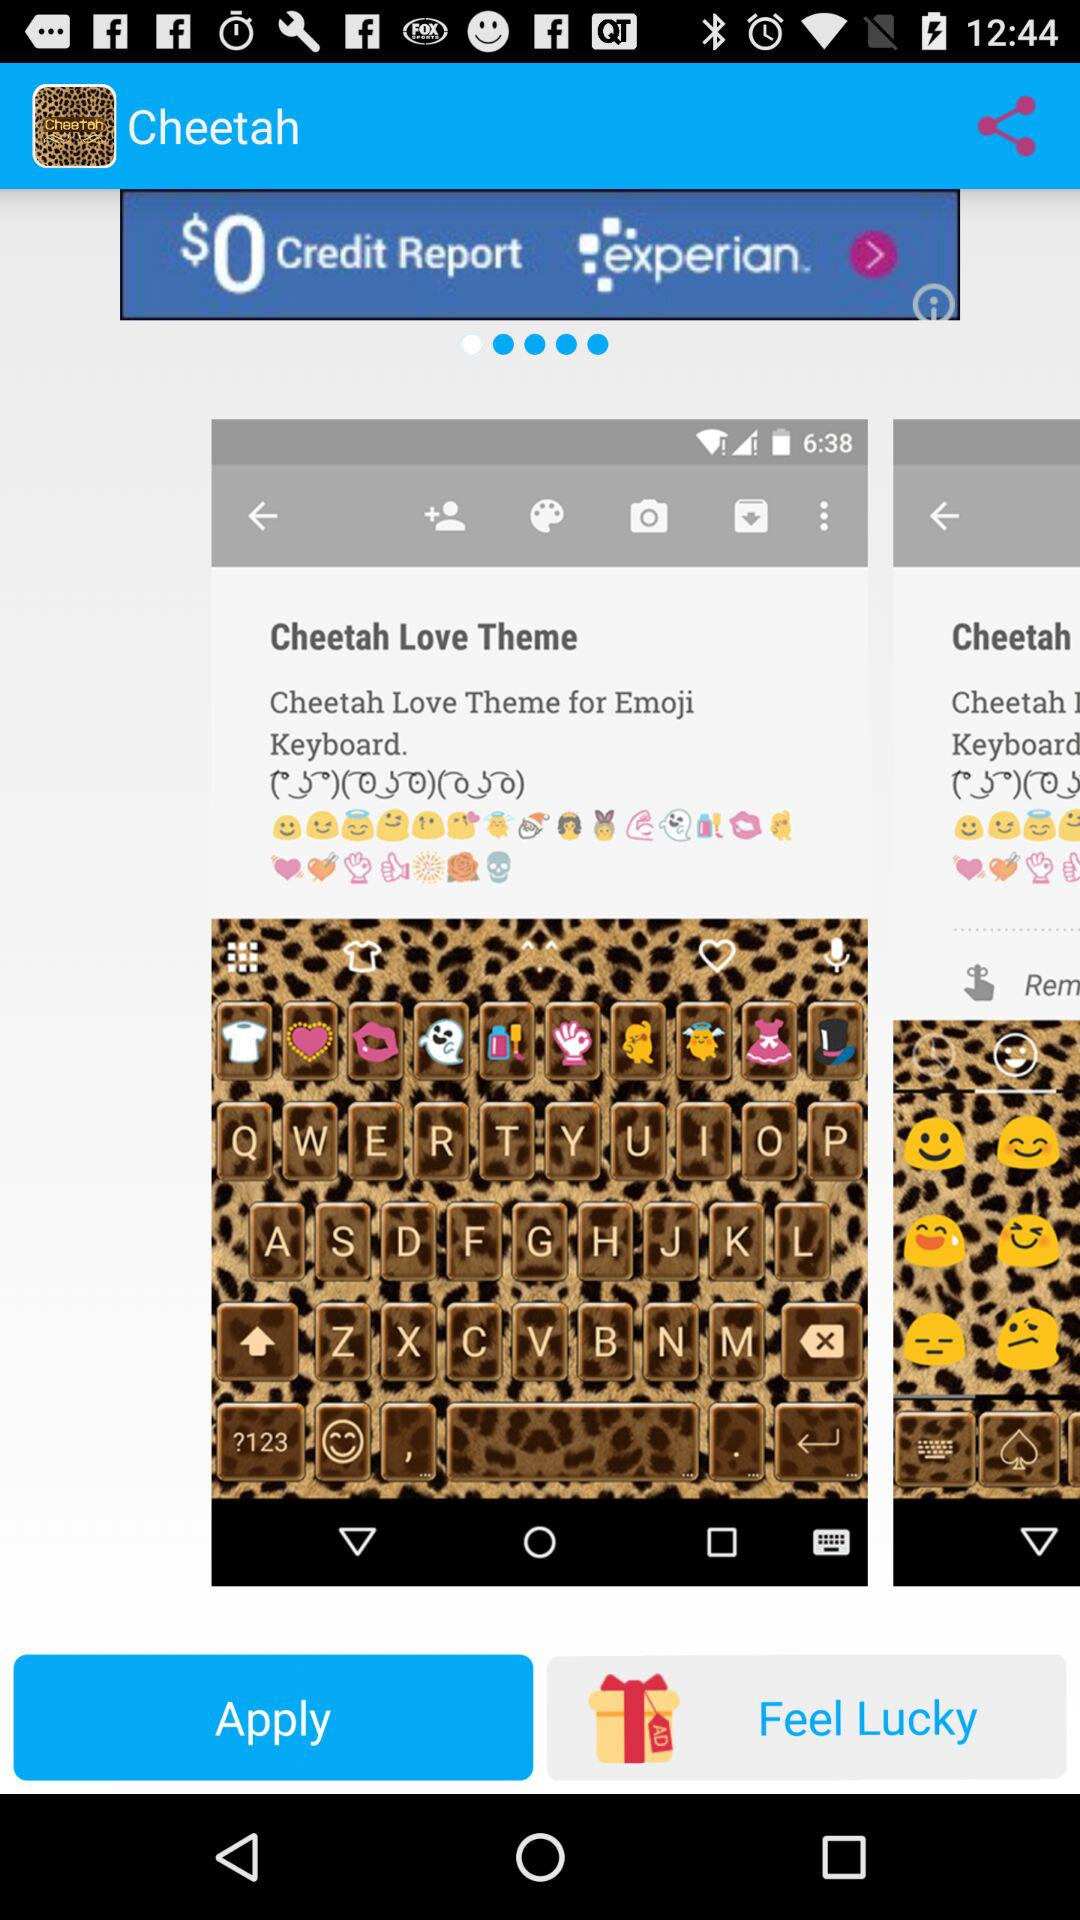What is the application name? The application name is "Cheetah". 